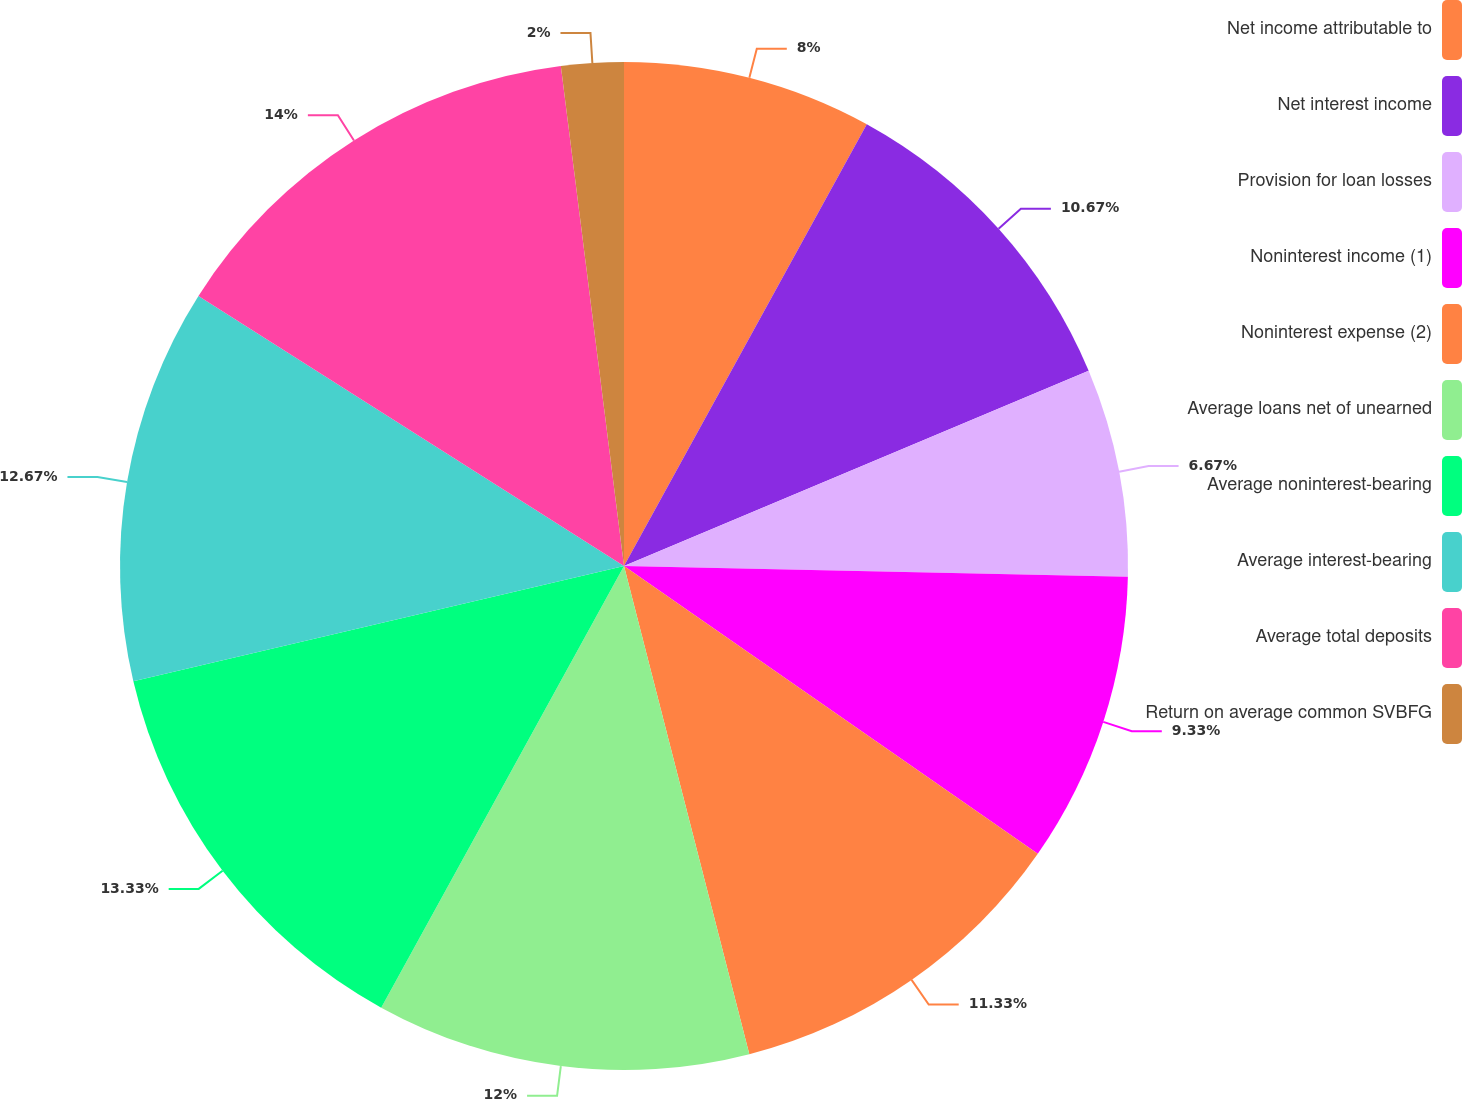<chart> <loc_0><loc_0><loc_500><loc_500><pie_chart><fcel>Net income attributable to<fcel>Net interest income<fcel>Provision for loan losses<fcel>Noninterest income (1)<fcel>Noninterest expense (2)<fcel>Average loans net of unearned<fcel>Average noninterest-bearing<fcel>Average interest-bearing<fcel>Average total deposits<fcel>Return on average common SVBFG<nl><fcel>8.0%<fcel>10.67%<fcel>6.67%<fcel>9.33%<fcel>11.33%<fcel>12.0%<fcel>13.33%<fcel>12.67%<fcel>14.0%<fcel>2.0%<nl></chart> 